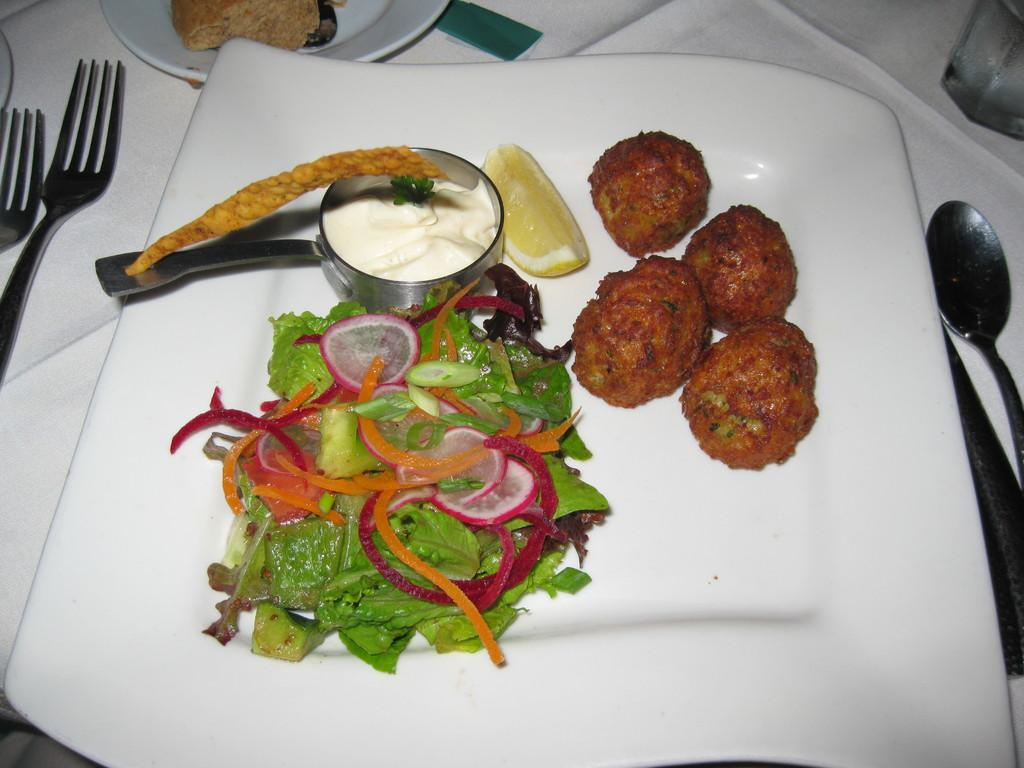What is present on the table in the image? There is a plate, food items, a bowl, a spoon, another plate, spoons, forks, and a glass on the table in the image. What type of utensils can be seen in the image? Spoons and forks are visible in the image. What is the purpose of the bowl in the image? The bowl is likely used for holding food items. How many plates are present in the image? There are two plates in the image. Who is the creator of the bun that is not present in the image? There is no bun mentioned or depicted in the image, so it is not possible to determine who its creator might be. 